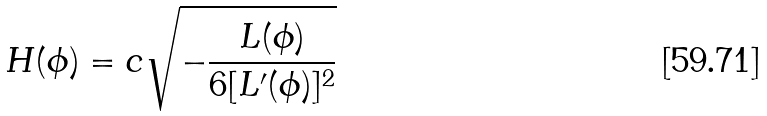Convert formula to latex. <formula><loc_0><loc_0><loc_500><loc_500>H ( \phi ) = c \sqrt { - \frac { L ( \phi ) } { 6 [ L ^ { \prime } ( \phi ) ] ^ { 2 } } }</formula> 